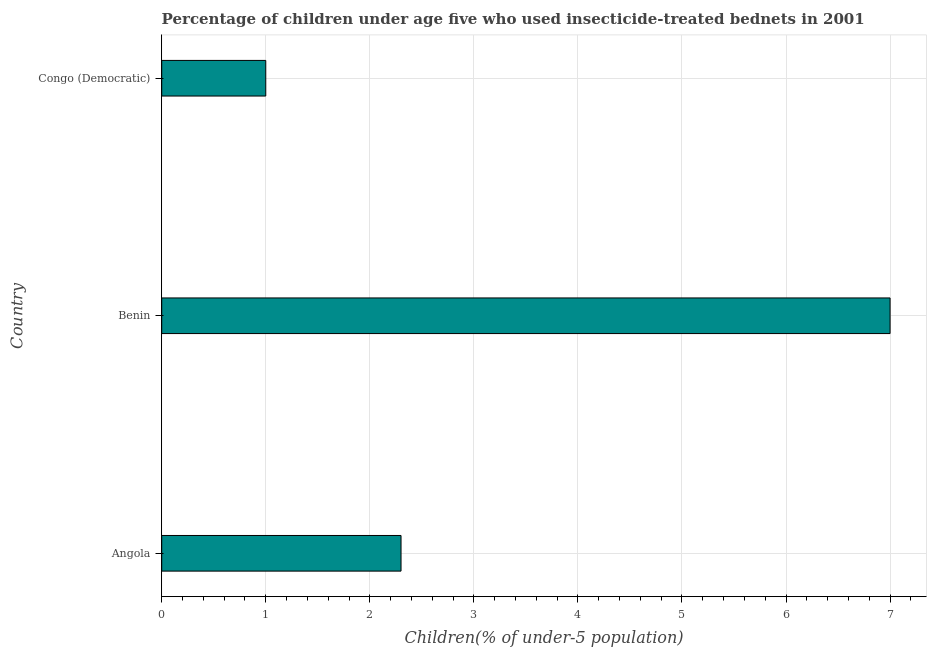Does the graph contain any zero values?
Provide a short and direct response. No. What is the title of the graph?
Your answer should be compact. Percentage of children under age five who used insecticide-treated bednets in 2001. What is the label or title of the X-axis?
Your response must be concise. Children(% of under-5 population). What is the label or title of the Y-axis?
Keep it short and to the point. Country. What is the percentage of children who use of insecticide-treated bed nets in Congo (Democratic)?
Give a very brief answer. 1. Across all countries, what is the maximum percentage of children who use of insecticide-treated bed nets?
Make the answer very short. 7. In which country was the percentage of children who use of insecticide-treated bed nets maximum?
Make the answer very short. Benin. In which country was the percentage of children who use of insecticide-treated bed nets minimum?
Your answer should be compact. Congo (Democratic). What is the sum of the percentage of children who use of insecticide-treated bed nets?
Ensure brevity in your answer.  10.3. What is the average percentage of children who use of insecticide-treated bed nets per country?
Make the answer very short. 3.43. What is the median percentage of children who use of insecticide-treated bed nets?
Make the answer very short. 2.3. What is the ratio of the percentage of children who use of insecticide-treated bed nets in Angola to that in Benin?
Provide a short and direct response. 0.33. Is the sum of the percentage of children who use of insecticide-treated bed nets in Angola and Congo (Democratic) greater than the maximum percentage of children who use of insecticide-treated bed nets across all countries?
Your response must be concise. No. How many bars are there?
Make the answer very short. 3. How many countries are there in the graph?
Make the answer very short. 3. What is the difference between two consecutive major ticks on the X-axis?
Offer a very short reply. 1. Are the values on the major ticks of X-axis written in scientific E-notation?
Ensure brevity in your answer.  No. What is the Children(% of under-5 population) in Angola?
Give a very brief answer. 2.3. What is the Children(% of under-5 population) of Congo (Democratic)?
Provide a succinct answer. 1. What is the difference between the Children(% of under-5 population) in Angola and Benin?
Make the answer very short. -4.7. What is the difference between the Children(% of under-5 population) in Benin and Congo (Democratic)?
Your answer should be compact. 6. What is the ratio of the Children(% of under-5 population) in Angola to that in Benin?
Provide a succinct answer. 0.33. What is the ratio of the Children(% of under-5 population) in Benin to that in Congo (Democratic)?
Ensure brevity in your answer.  7. 